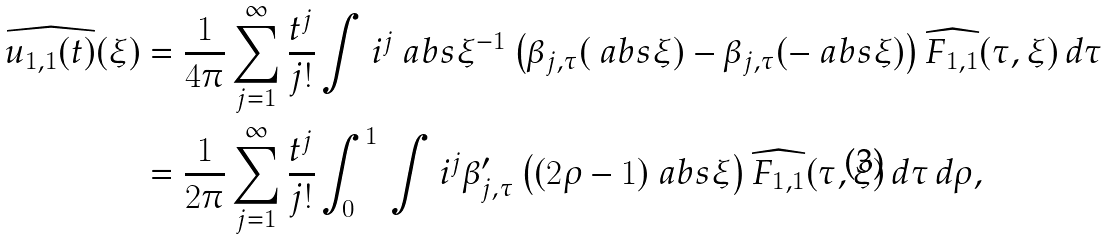Convert formula to latex. <formula><loc_0><loc_0><loc_500><loc_500>\widehat { u _ { 1 , 1 } ( t ) } ( \xi ) & = \frac { 1 } { 4 \pi } \sum _ { j = 1 } ^ { \infty } \frac { t ^ { j } } { j ! } \int i ^ { j } \ a b s { \xi } ^ { - 1 } \left ( \beta _ { j , \tau } ( \ a b s { \xi } ) - \beta _ { j , \tau } ( - \ a b s { \xi } ) \right ) \widehat { F _ { 1 , 1 } } ( \tau , \xi ) \, d \tau \\ & = \frac { 1 } { 2 \pi } \sum _ { j = 1 } ^ { \infty } \frac { t ^ { j } } { j ! } \int _ { 0 } ^ { 1 } \, \int i ^ { j } \beta _ { j , \tau } ^ { \prime } \left ( ( 2 \rho - 1 ) \ a b s { \xi } \right ) \widehat { F _ { 1 , 1 } } ( \tau , \xi ) \, d \tau \, d \rho ,</formula> 